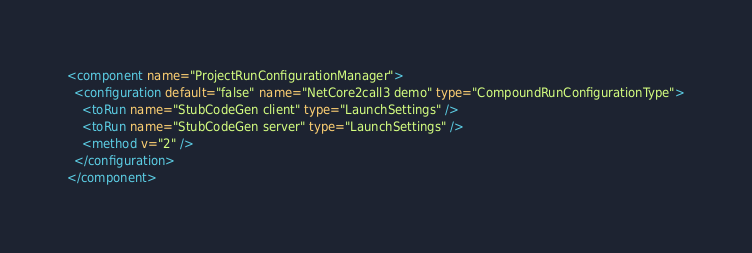Convert code to text. <code><loc_0><loc_0><loc_500><loc_500><_XML_><component name="ProjectRunConfigurationManager">
  <configuration default="false" name="NetCore2call3 demo" type="CompoundRunConfigurationType">
    <toRun name="StubCodeGen client" type="LaunchSettings" />
    <toRun name="StubCodeGen server" type="LaunchSettings" />
    <method v="2" />
  </configuration>
</component></code> 